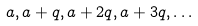<formula> <loc_0><loc_0><loc_500><loc_500>a , a + q , a + 2 q , a + 3 q , \dots</formula> 